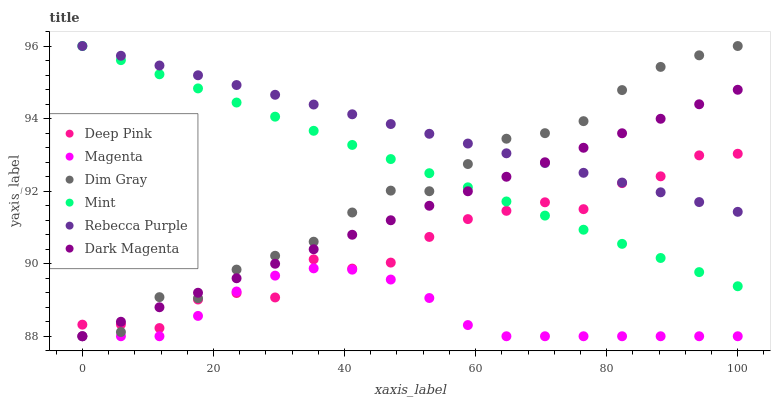Does Magenta have the minimum area under the curve?
Answer yes or no. Yes. Does Rebecca Purple have the maximum area under the curve?
Answer yes or no. Yes. Does Dark Magenta have the minimum area under the curve?
Answer yes or no. No. Does Dark Magenta have the maximum area under the curve?
Answer yes or no. No. Is Dark Magenta the smoothest?
Answer yes or no. Yes. Is Deep Pink the roughest?
Answer yes or no. Yes. Is Dim Gray the smoothest?
Answer yes or no. No. Is Dim Gray the roughest?
Answer yes or no. No. Does Dark Magenta have the lowest value?
Answer yes or no. Yes. Does Rebecca Purple have the lowest value?
Answer yes or no. No. Does Mint have the highest value?
Answer yes or no. Yes. Does Dark Magenta have the highest value?
Answer yes or no. No. Is Magenta less than Mint?
Answer yes or no. Yes. Is Rebecca Purple greater than Magenta?
Answer yes or no. Yes. Does Deep Pink intersect Rebecca Purple?
Answer yes or no. Yes. Is Deep Pink less than Rebecca Purple?
Answer yes or no. No. Is Deep Pink greater than Rebecca Purple?
Answer yes or no. No. Does Magenta intersect Mint?
Answer yes or no. No. 